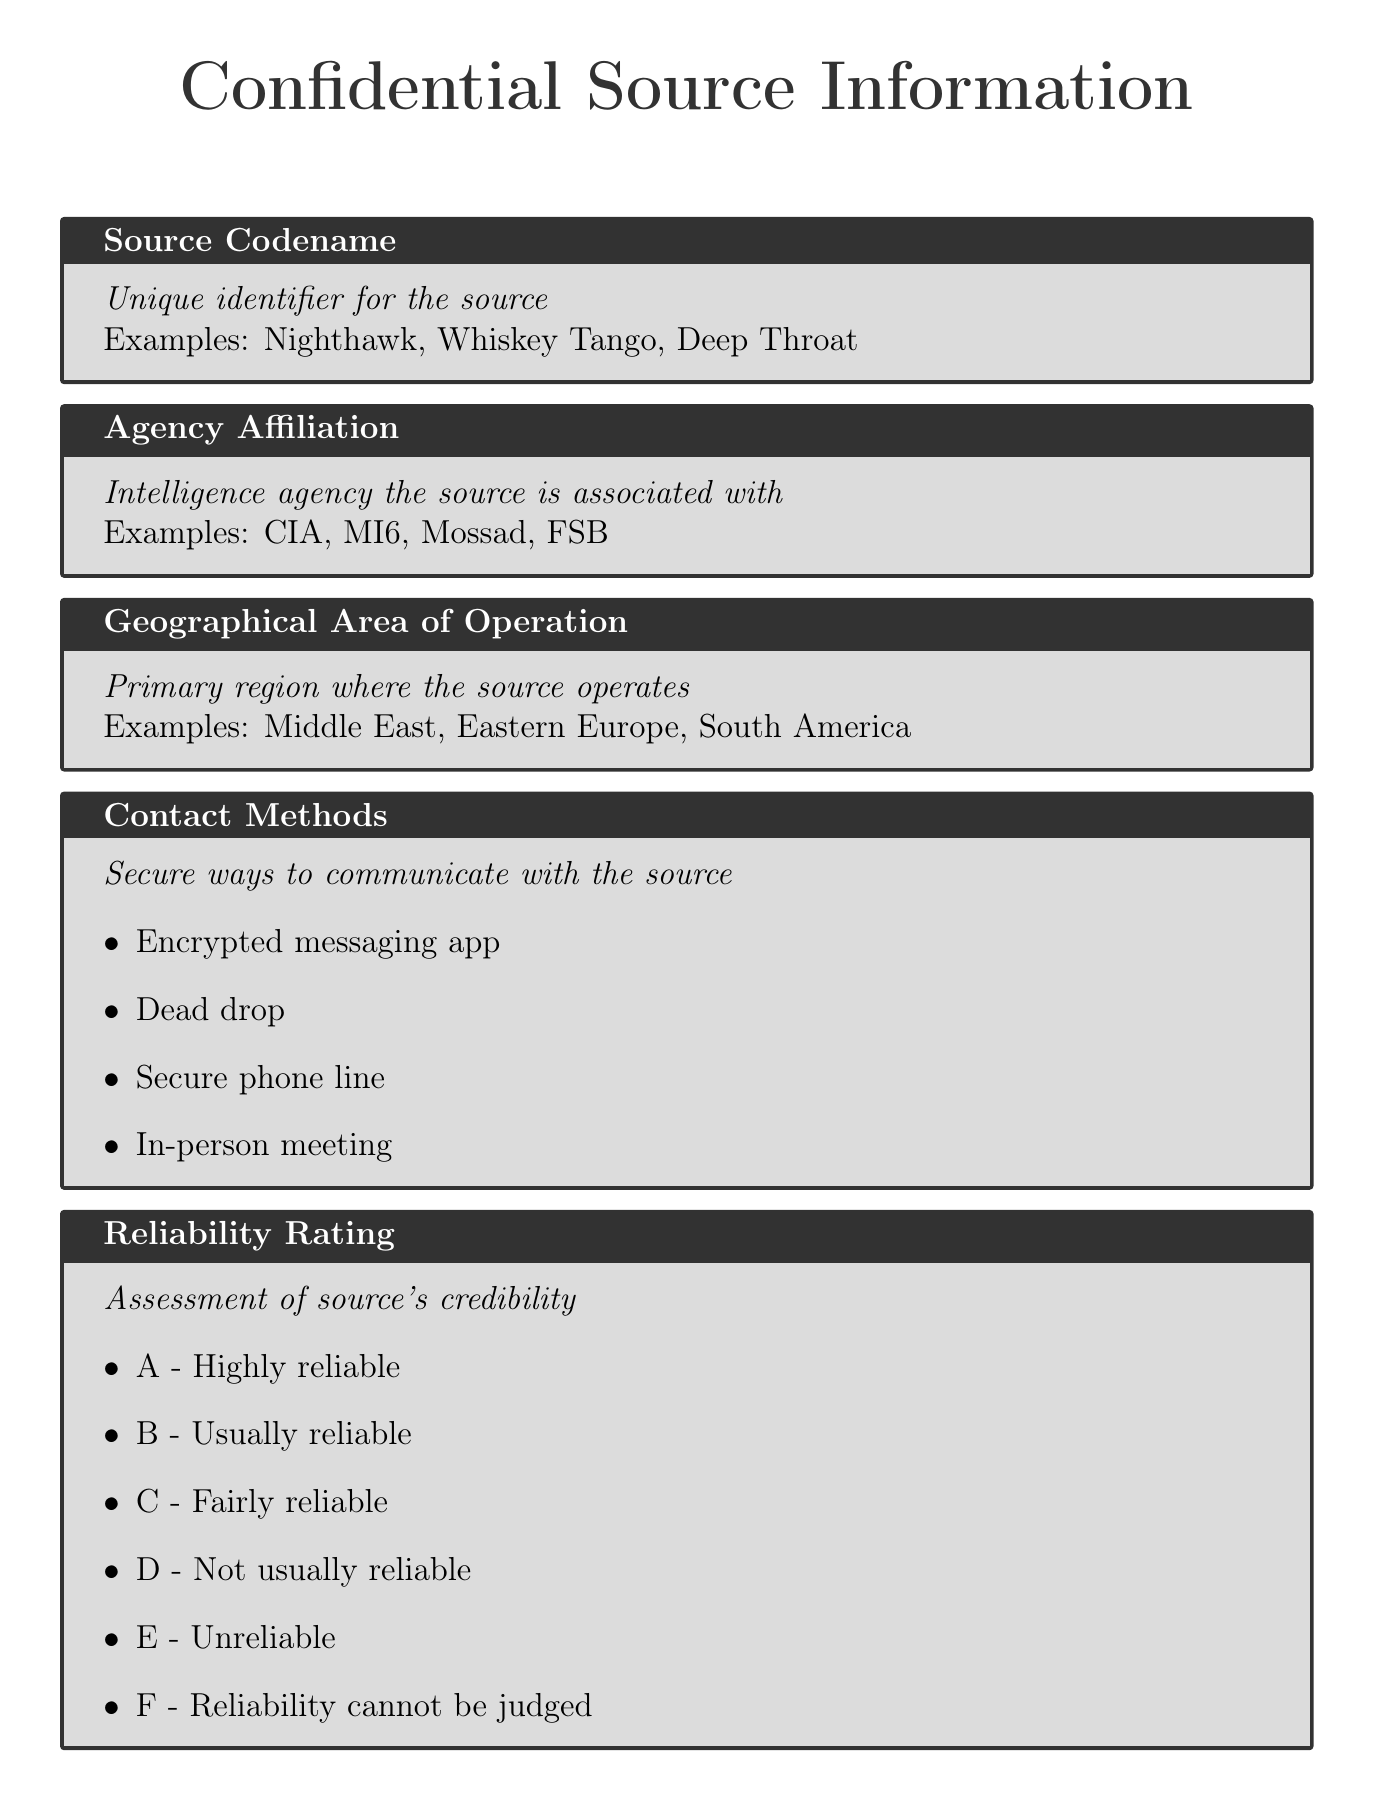what is the source codename? The source codename is a unique identifier for the source given in the document.
Answer: Nighthawk which intelligence agency is the source affiliated with? This refers to the intelligence agency that the source is associated with, as listed in the document.
Answer: CIA what is the geographical area of operation for the source? This field indicates the primary region where the source operates, as provided in the document.
Answer: Middle East what are the secure contact methods listed? This asks for the ways to communicate securely with the source, as outlined in the document.
Answer: Encrypted messaging app what is the lowest reliability rating in the scale provided? The document includes a scale for reliability ratings; this question seeks the lowest rating listed.
Answer: E - Unreliable what level of access does the source have to sensitive information? This question refers to the category of information access level for the source according to the document.
Answer: Top-level decision maker what type of risk assessment is associated with the source? A risk assessment evaluates potential risks; this question is looking for the type listed in the document.
Answer: Low risk who is the handler for the source? The handler is the agency officer managing the source, which is detailed in the document.
Answer: Agent Smith what notable intelligence contribution has the source made? This looks for significant information the source has provided as highlighted in the document.
Answer: Exposed election interference operation 